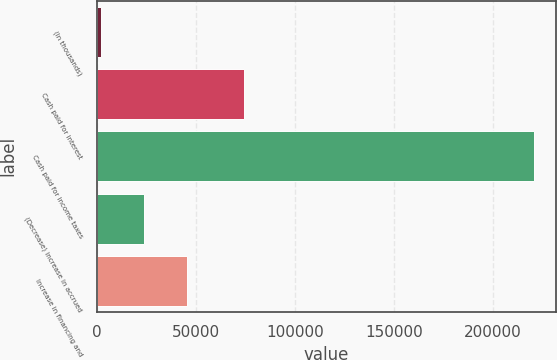Convert chart. <chart><loc_0><loc_0><loc_500><loc_500><bar_chart><fcel>(In thousands)<fcel>Cash paid for interest<fcel>Cash paid for income taxes<fcel>(Decrease) increase in accrued<fcel>Increase in financing and<nl><fcel>2019<fcel>74204<fcel>220669<fcel>23884<fcel>45749<nl></chart> 